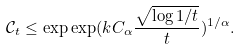Convert formula to latex. <formula><loc_0><loc_0><loc_500><loc_500>\mathcal { C } _ { t } \leq \exp \exp ( k C _ { \alpha } \frac { \sqrt { \log 1 / t } } { t } ) ^ { 1 / \alpha } .</formula> 